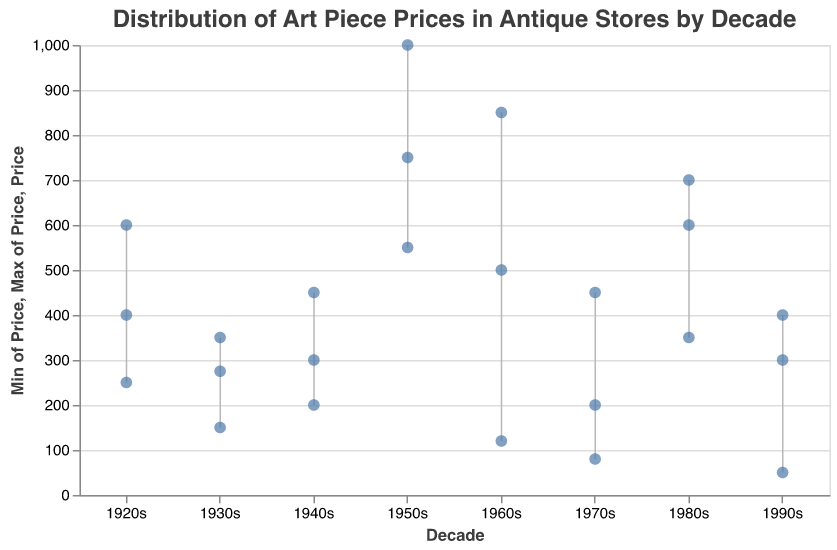What is the title of the figure? The title of the figure is displayed at the top and describes the content of the plot. It reads: "Distribution of Art Piece Prices in Antique Stores by Decade".
Answer: Distribution of Art Piece Prices in Antique Stores by Decade How many data points are there in the 1950s? Each dot in the figure represents a data point, and we can count the dots within the 1950s range. There are 3 dots for the 1950s.
Answer: 3 Which decade has the highest maximum price and what is that price? To determine this, we look for the decade with the highest point on the y-axis. The 1950s has the highest point at 1000.
Answer: 1950s, 1000 What is the price range of art pieces from the 1970s? To identify the range, we find the minimum and maximum prices for the 1970s from the y-axis positions of the points associated with this decade. The minimum is 80 and the maximum is 450.
Answer: 80-450 Which decade has the lowest minimum price and what is that price? We need to look for the point that is closest to the bottom of the y-axis across all decades. The 1990s has the lowest point at 50.
Answer: 1990s, 50 What is the average price of art pieces from the 1960s? First, sum the prices of the 1960s art pieces: 120 (Psychedelic Poster) + 850 (Pop Art Painting) + 500 (Modernist Lamp) = 1470. Then, divide by the number of pieces, 3. 1470/3 = 490
Answer: 490 Which decade has the smallest range of prices? The range is calculated by subtracting the minimum price from the maximum price for each decade. The 1990s have a range of 400 - 50 = 350, which is the smallest among all decades.
Answer: 1990s Are there more art pieces with prices above 500 in the 1950s or 1980s? We count the number of points above 500 for both decades. The 1950s have 2 points (1000, 750) and the 1980s have 1 point (700).
Answer: 1950s Do any decades have art pieces priced exactly at 200? We check whether any points lie exactly on the 200-price level. Both the 1940s and 1970s have one art piece each priced at 200.
Answer: Yes What is the median price of art pieces from the 1940s? To find the median, we need to list prices in the 1940s in ascending order: 200, 300, 450. The middle number is 300, so the median price is 300.
Answer: 300 Which decade has the largest number of distinct price points? We count the distinct price points for each decade. The 1980s have 3 distinct prices (350, 600, 700), which is the largest amongst all decades.
Answer: 1980s 